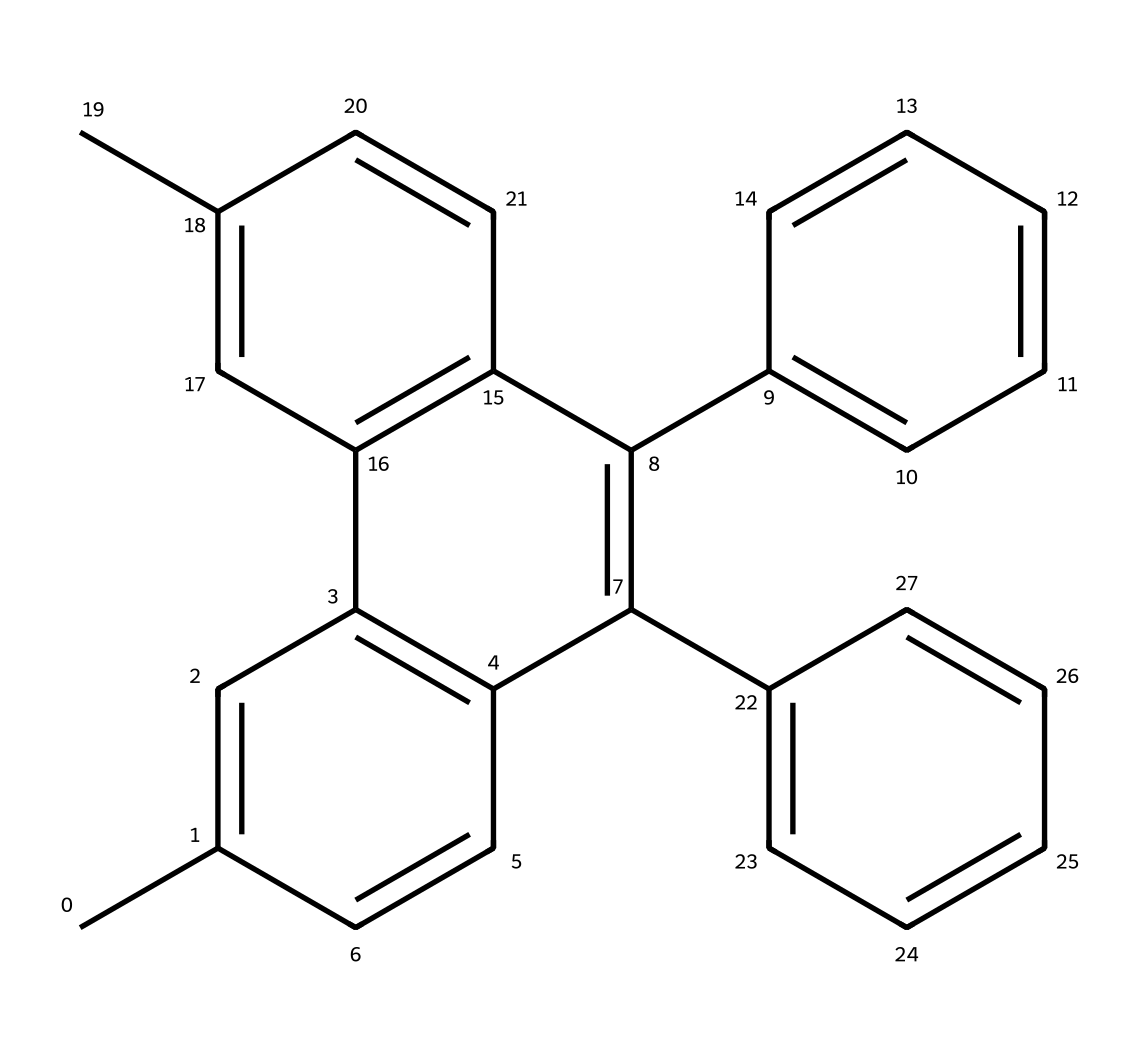How many carbon atoms are present in this chemical structure? To find the number of carbon atoms, we analyze the SMILES representation. Each 'C' in the SMILES denotes a carbon atom. By counting each 'C,' we can determine there are 24 carbon atoms in total.
Answer: 24 What type of functional groups are present in this dye? In the provided chemical structure, there are no distinct functional groups like hydroxyl or carboxyl groups indicated. Instead, it is primarily composed of carbon and hydrogen atoms. Hence, it can primarily be classified as an aromatic compound due to the presence of multiple benzene rings, but it does not have specific functional groups characteristic of other dye types.
Answer: aromatic compound What is the degree of saturation of this dye? Degree of saturation can be determined by the number of rings and double bonds present. Each benzene ring contributes to saturation, and corresponding double bonds add to the saturation level. In this structure, there are multiple double bonds and rings, indicating that this molecule has a high degree of saturation. Evaluating the structure through the rings suggests multiple conjugated systems that stabilize the molecule.
Answer: high Is this dye likely to be soluble in water? Water solubility generally depends on the presence of polar functional groups. The absence of such groups in this structure, coupled with the presence of a large hydrocarbon backbone, indicates that this dye is non-polar. Thus, it is expected to have low solubility in water.
Answer: low How many rings are found in this chemical structure? By analyzing the structure in the SMILES, we can identify that there are a total of 3 distinct fused rings. Ring structures contribute to certain properties typical of organic dyes.
Answer: 3 What is the primary use of this type of dye? Photochromic dyes are typically used for their ability to change color in response to light exposure. This property makes them ideal for applications such as smart glasses for augmented reality, allowing the lenses to adapt to changing light conditions and improve visual comfort.
Answer: smart glasses 